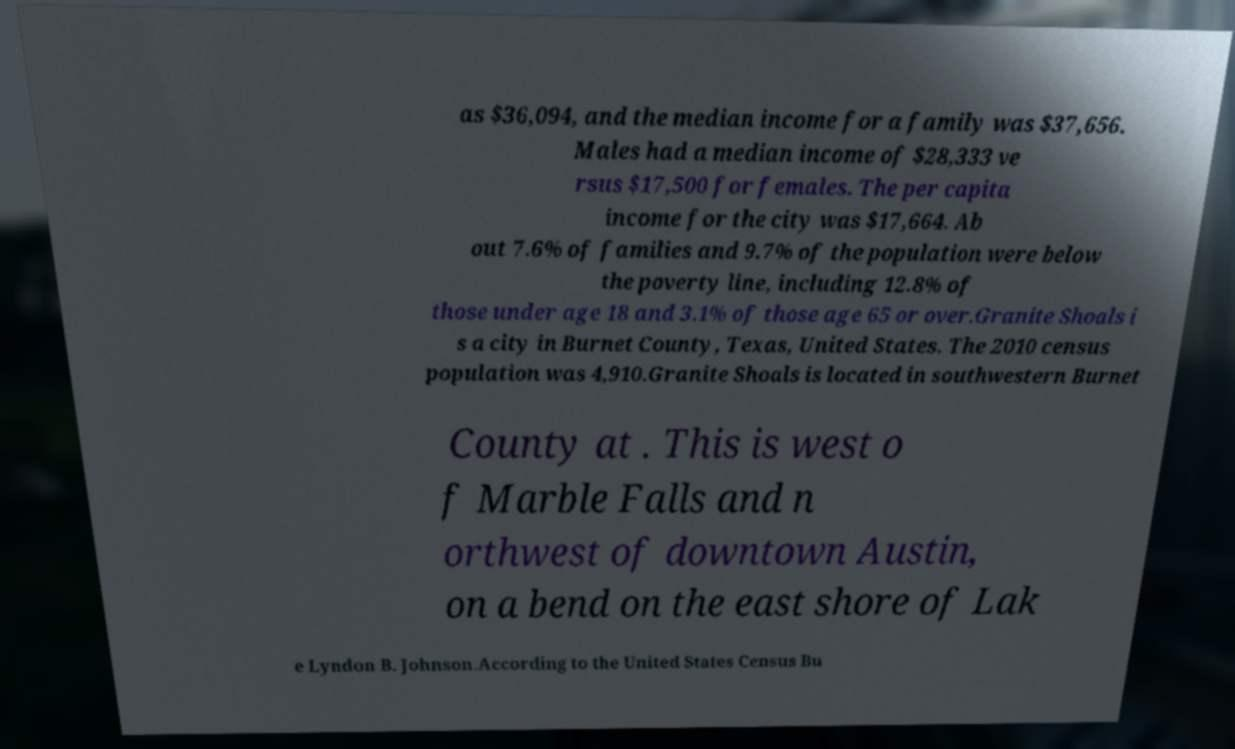For documentation purposes, I need the text within this image transcribed. Could you provide that? as $36,094, and the median income for a family was $37,656. Males had a median income of $28,333 ve rsus $17,500 for females. The per capita income for the city was $17,664. Ab out 7.6% of families and 9.7% of the population were below the poverty line, including 12.8% of those under age 18 and 3.1% of those age 65 or over.Granite Shoals i s a city in Burnet County, Texas, United States. The 2010 census population was 4,910.Granite Shoals is located in southwestern Burnet County at . This is west o f Marble Falls and n orthwest of downtown Austin, on a bend on the east shore of Lak e Lyndon B. Johnson.According to the United States Census Bu 